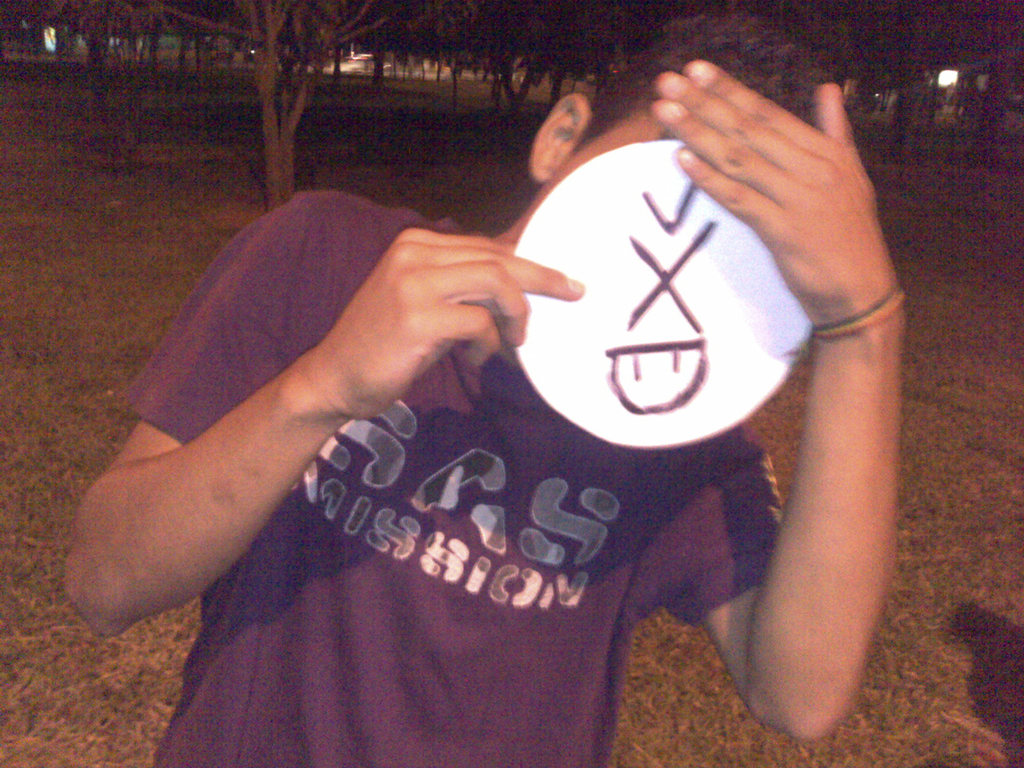Provide a one-sentence caption for the provided image. A young individual playfully interacts with the camera by holding up a homemade mask with a drawn face, while wearing a purple t-shirt labeled 'SAS Mission', invoking a sense of mystery and humor. 